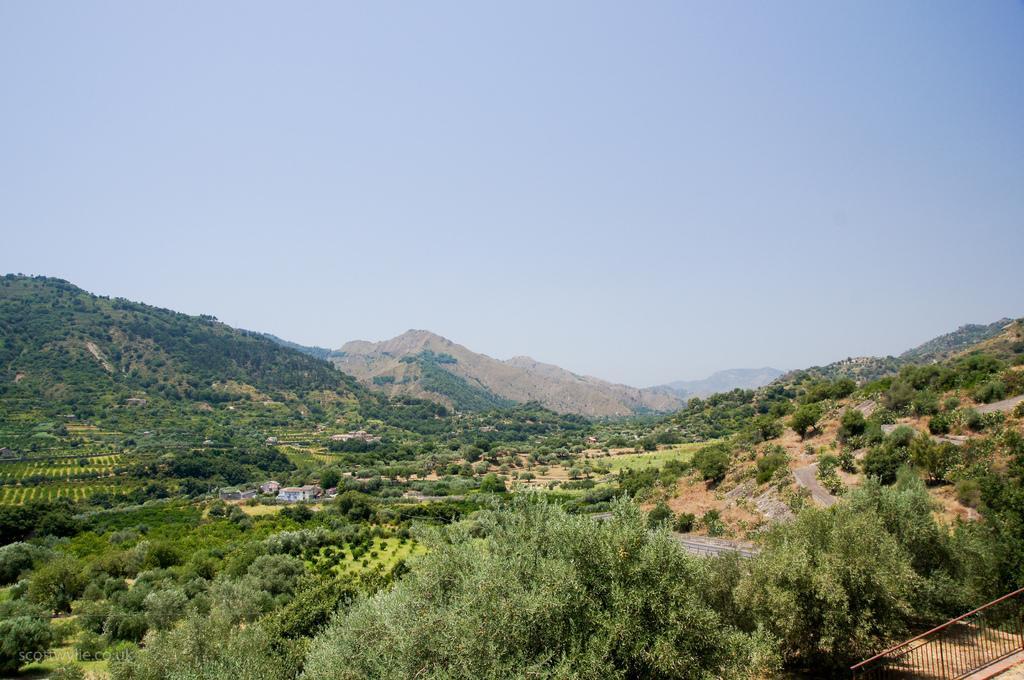Can you describe this image briefly? In this image I can see the hill view and I can see the sky and trees visible 